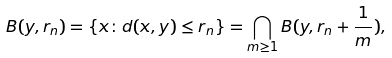Convert formula to latex. <formula><loc_0><loc_0><loc_500><loc_500>B ( y , r _ { n } ) = \{ x \colon d ( x , y ) \leq r _ { n } \} = \bigcap _ { m \geq 1 } B ( y , r _ { n } + \frac { 1 } { m } ) ,</formula> 